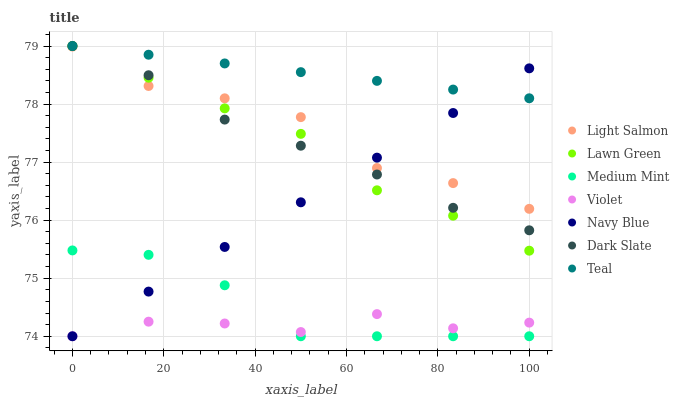Does Violet have the minimum area under the curve?
Answer yes or no. Yes. Does Teal have the maximum area under the curve?
Answer yes or no. Yes. Does Lawn Green have the minimum area under the curve?
Answer yes or no. No. Does Lawn Green have the maximum area under the curve?
Answer yes or no. No. Is Teal the smoothest?
Answer yes or no. Yes. Is Light Salmon the roughest?
Answer yes or no. Yes. Is Lawn Green the smoothest?
Answer yes or no. No. Is Lawn Green the roughest?
Answer yes or no. No. Does Medium Mint have the lowest value?
Answer yes or no. Yes. Does Lawn Green have the lowest value?
Answer yes or no. No. Does Teal have the highest value?
Answer yes or no. Yes. Does Light Salmon have the highest value?
Answer yes or no. No. Is Medium Mint less than Dark Slate?
Answer yes or no. Yes. Is Light Salmon greater than Medium Mint?
Answer yes or no. Yes. Does Light Salmon intersect Navy Blue?
Answer yes or no. Yes. Is Light Salmon less than Navy Blue?
Answer yes or no. No. Is Light Salmon greater than Navy Blue?
Answer yes or no. No. Does Medium Mint intersect Dark Slate?
Answer yes or no. No. 